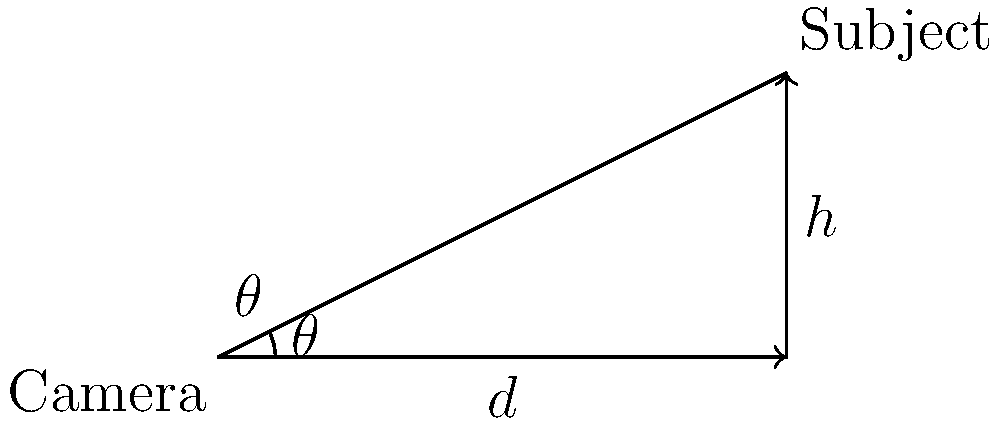As a TV Executive Producer, you're setting up a wide-angle shot for a new reality show. The camera is positioned at ground level, and the subject is 10 meters away horizontally and 5 meters above ground. What angle $\theta$ should the camera be tilted upwards to capture the entire subject in the frame? To solve this problem, we'll use basic trigonometry:

1. We have a right triangle with the following measurements:
   - Adjacent side (horizontal distance): $d = 10$ meters
   - Opposite side (vertical height): $h = 5$ meters
   - We need to find the angle $\theta$

2. The tangent of an angle in a right triangle is defined as the ratio of the opposite side to the adjacent side:

   $\tan(\theta) = \frac{\text{opposite}}{\text{adjacent}} = \frac{h}{d}$

3. Substituting our known values:

   $\tan(\theta) = \frac{5}{10} = 0.5$

4. To find $\theta$, we need to use the inverse tangent (arctangent) function:

   $\theta = \arctan(0.5)$

5. Using a calculator or trigonometric tables:

   $\theta \approx 26.57°$

Therefore, the camera should be tilted upwards at an angle of approximately 26.57 degrees to capture the entire subject in the wide-angle shot.
Answer: $26.57°$ 